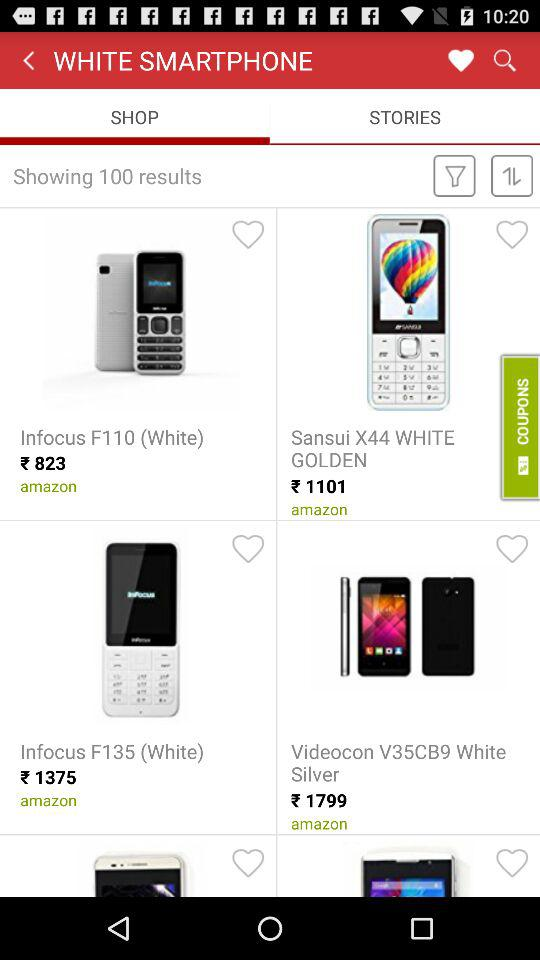What is the currency of price? The currency of price is rupees. 